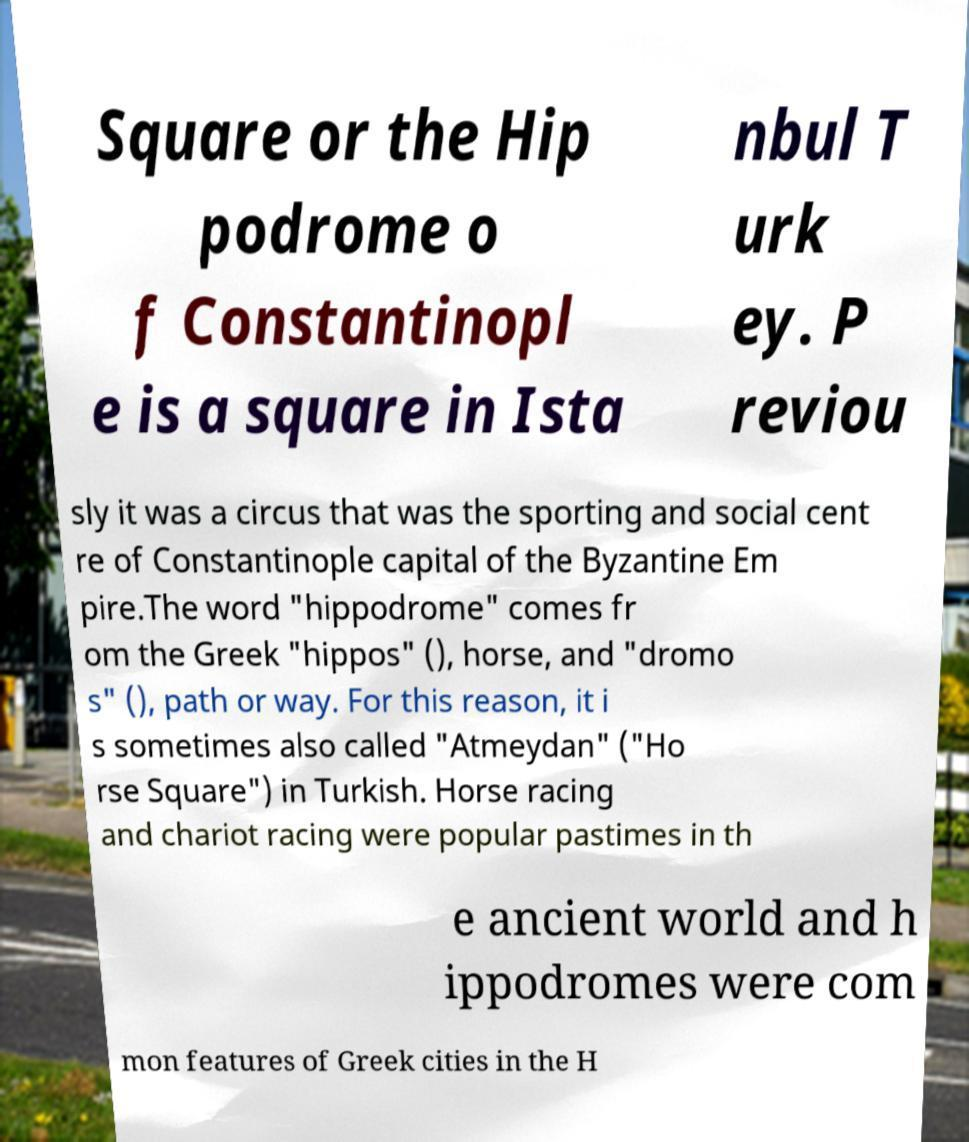There's text embedded in this image that I need extracted. Can you transcribe it verbatim? Square or the Hip podrome o f Constantinopl e is a square in Ista nbul T urk ey. P reviou sly it was a circus that was the sporting and social cent re of Constantinople capital of the Byzantine Em pire.The word "hippodrome" comes fr om the Greek "hippos" (), horse, and "dromo s" (), path or way. For this reason, it i s sometimes also called "Atmeydan" ("Ho rse Square") in Turkish. Horse racing and chariot racing were popular pastimes in th e ancient world and h ippodromes were com mon features of Greek cities in the H 